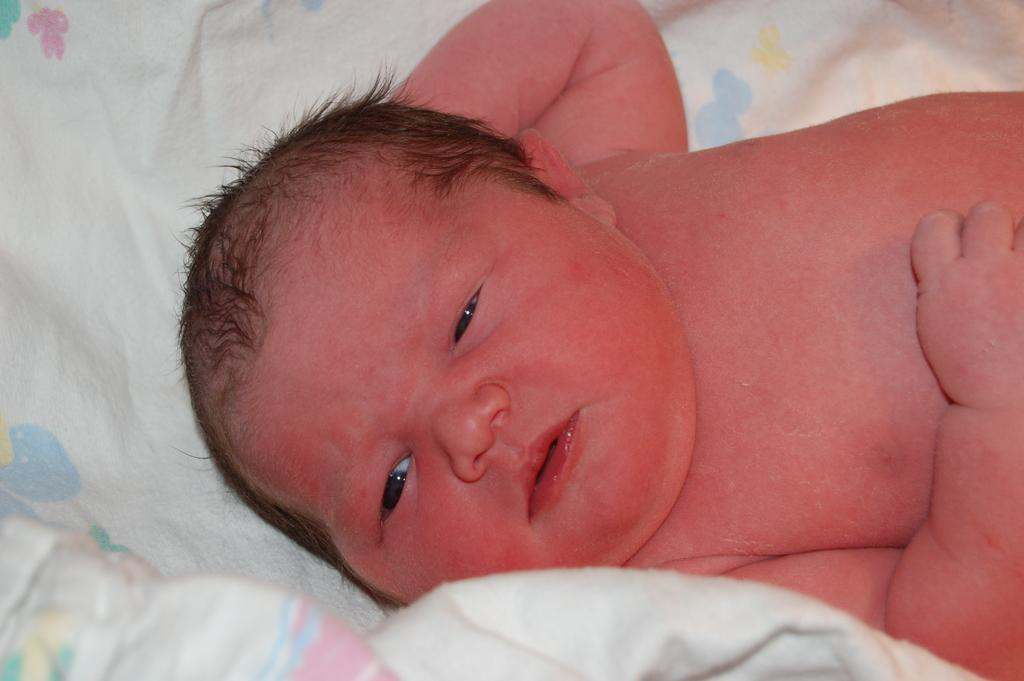What is the main subject of the image? There is a baby in the image. What colors can be seen on the baby? The baby has orange, red, and black colors. What is the baby resting on in the image? The baby is on a cloth. What colors can be seen on the cloth? The cloth has white, pink, green, blue, and yellow colors. What caption is written on the baby's forehead in the image? There is no caption written on the baby's forehead in the image. 